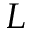Convert formula to latex. <formula><loc_0><loc_0><loc_500><loc_500>L</formula> 